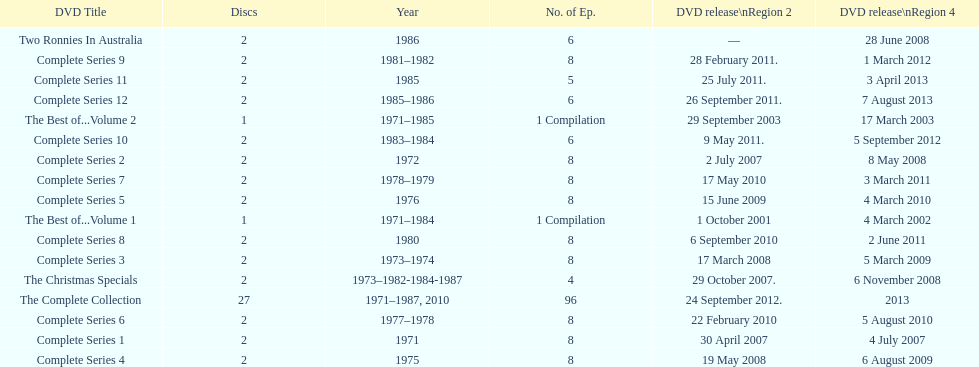Total number of episodes released in region 2 in 2007 20. 